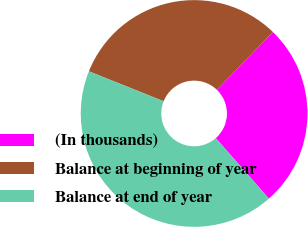<chart> <loc_0><loc_0><loc_500><loc_500><pie_chart><fcel>(In thousands)<fcel>Balance at beginning of year<fcel>Balance at end of year<nl><fcel>26.31%<fcel>31.16%<fcel>42.53%<nl></chart> 